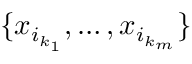Convert formula to latex. <formula><loc_0><loc_0><loc_500><loc_500>\{ x _ { i _ { k _ { 1 } } } , \dots , x _ { i _ { k _ { m } } } \}</formula> 